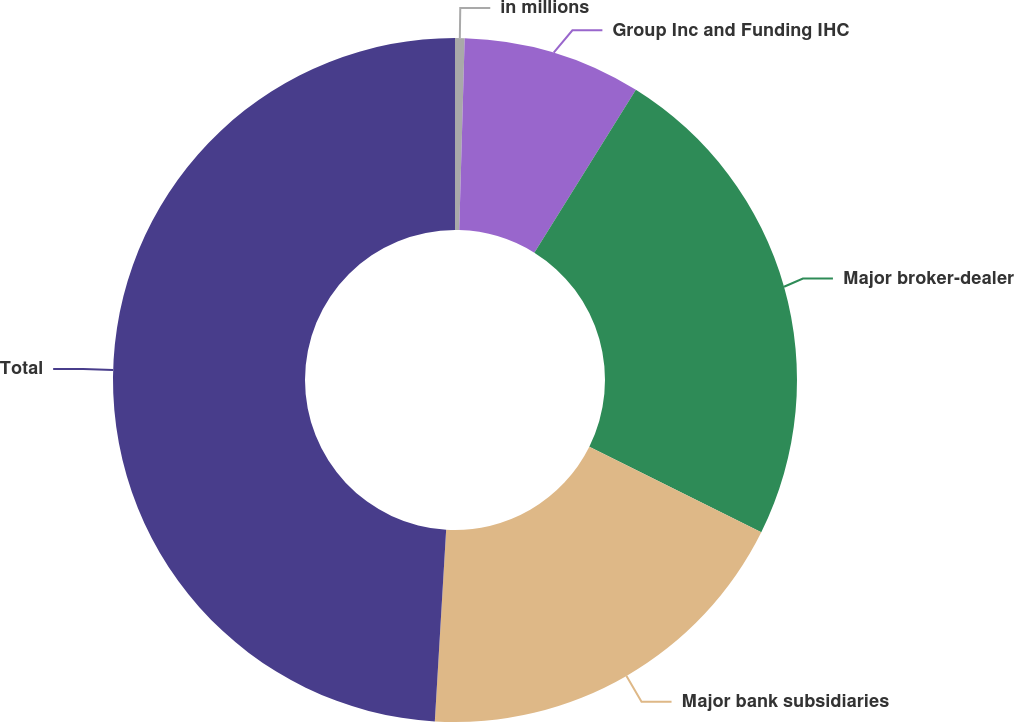Convert chart to OTSL. <chart><loc_0><loc_0><loc_500><loc_500><pie_chart><fcel>in millions<fcel>Group Inc and Funding IHC<fcel>Major broker-dealer<fcel>Major bank subsidiaries<fcel>Total<nl><fcel>0.45%<fcel>8.42%<fcel>23.47%<fcel>18.6%<fcel>49.06%<nl></chart> 